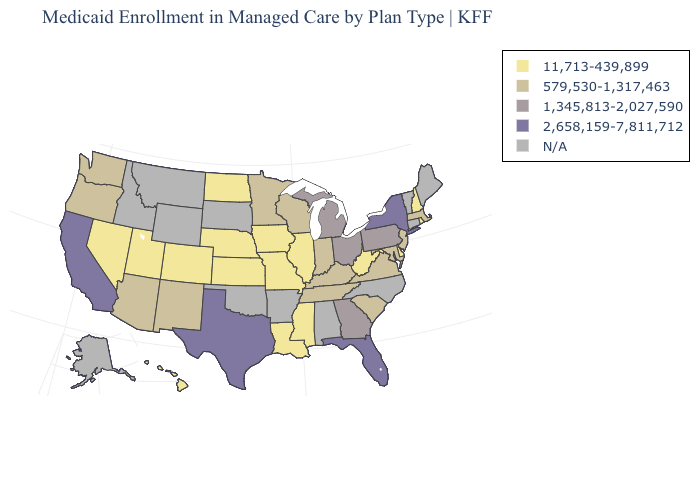What is the value of Virginia?
Be succinct. 579,530-1,317,463. Does the map have missing data?
Quick response, please. Yes. Name the states that have a value in the range 11,713-439,899?
Short answer required. Colorado, Delaware, Hawaii, Illinois, Iowa, Kansas, Louisiana, Mississippi, Missouri, Nebraska, Nevada, New Hampshire, North Dakota, Rhode Island, Utah, West Virginia. Among the states that border Mississippi , which have the highest value?
Quick response, please. Tennessee. Name the states that have a value in the range 11,713-439,899?
Quick response, please. Colorado, Delaware, Hawaii, Illinois, Iowa, Kansas, Louisiana, Mississippi, Missouri, Nebraska, Nevada, New Hampshire, North Dakota, Rhode Island, Utah, West Virginia. Does New York have the highest value in the Northeast?
Give a very brief answer. Yes. What is the value of Mississippi?
Answer briefly. 11,713-439,899. What is the lowest value in the USA?
Concise answer only. 11,713-439,899. Name the states that have a value in the range 579,530-1,317,463?
Be succinct. Arizona, Indiana, Kentucky, Maryland, Massachusetts, Minnesota, New Jersey, New Mexico, Oregon, South Carolina, Tennessee, Virginia, Washington, Wisconsin. Among the states that border Michigan , does Wisconsin have the highest value?
Be succinct. No. Name the states that have a value in the range N/A?
Concise answer only. Alabama, Alaska, Arkansas, Connecticut, Idaho, Maine, Montana, North Carolina, Oklahoma, South Dakota, Vermont, Wyoming. Which states hav the highest value in the Northeast?
Keep it brief. New York. Among the states that border Iowa , does Wisconsin have the highest value?
Answer briefly. Yes. What is the value of Oregon?
Answer briefly. 579,530-1,317,463. Does Kansas have the lowest value in the USA?
Quick response, please. Yes. 